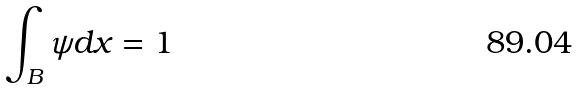Convert formula to latex. <formula><loc_0><loc_0><loc_500><loc_500>\int _ { B } \psi d x = 1</formula> 